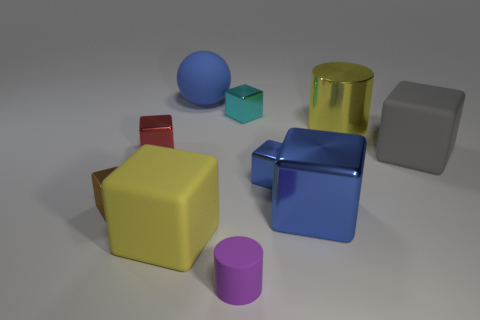Subtract all large blocks. How many blocks are left? 4 Subtract all purple cylinders. How many cylinders are left? 1 Subtract all spheres. How many objects are left? 9 Subtract all yellow spheres. How many blue blocks are left? 2 Subtract 6 cubes. How many cubes are left? 1 Add 5 yellow rubber cubes. How many yellow rubber cubes are left? 6 Add 7 red shiny objects. How many red shiny objects exist? 8 Subtract 0 blue cylinders. How many objects are left? 10 Subtract all purple cubes. Subtract all green spheres. How many cubes are left? 7 Subtract all red metallic blocks. Subtract all small blue things. How many objects are left? 8 